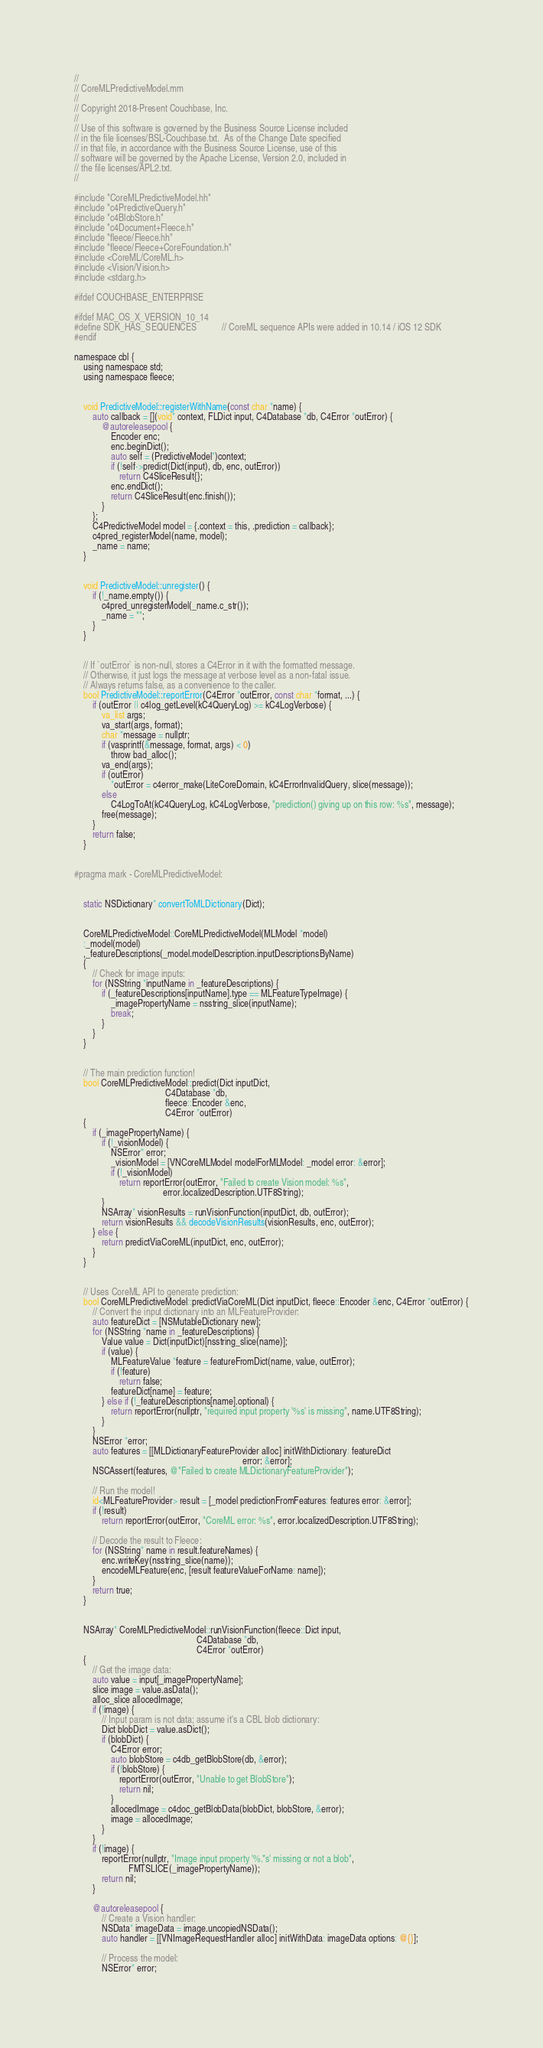<code> <loc_0><loc_0><loc_500><loc_500><_ObjectiveC_>//
// CoreMLPredictiveModel.mm
//
// Copyright 2018-Present Couchbase, Inc.
//
// Use of this software is governed by the Business Source License included
// in the file licenses/BSL-Couchbase.txt.  As of the Change Date specified
// in that file, in accordance with the Business Source License, use of this
// software will be governed by the Apache License, Version 2.0, included in
// the file licenses/APL2.txt.
//

#include "CoreMLPredictiveModel.hh"
#include "c4PredictiveQuery.h"
#include "c4BlobStore.h"
#include "c4Document+Fleece.h"
#include "fleece/Fleece.hh"
#include "fleece/Fleece+CoreFoundation.h"
#include <CoreML/CoreML.h>
#include <Vision/Vision.h>
#include <stdarg.h>

#ifdef COUCHBASE_ENTERPRISE

#ifdef MAC_OS_X_VERSION_10_14
#define SDK_HAS_SEQUENCES           // CoreML sequence APIs were added in 10.14 / iOS 12 SDK
#endif

namespace cbl {
    using namespace std;
    using namespace fleece;


    void PredictiveModel::registerWithName(const char *name) {
        auto callback = [](void* context, FLDict input, C4Database *db, C4Error *outError) {
            @autoreleasepool {
                Encoder enc;
                enc.beginDict();
                auto self = (PredictiveModel*)context;
                if (!self->predict(Dict(input), db, enc, outError))
                    return C4SliceResult{};
                enc.endDict();
                return C4SliceResult(enc.finish());
            }
        };
        C4PredictiveModel model = {.context = this, .prediction = callback};
        c4pred_registerModel(name, model);
        _name = name;
    }


    void PredictiveModel::unregister() {
        if (!_name.empty()) {
            c4pred_unregisterModel(_name.c_str());
            _name = "";
        }
    }


    // If `outError` is non-null, stores a C4Error in it with the formatted message.
    // Otherwise, it just logs the message at verbose level as a non-fatal issue.
    // Always returns false, as a convenience to the caller.
    bool PredictiveModel::reportError(C4Error *outError, const char *format, ...) {
        if (outError || c4log_getLevel(kC4QueryLog) >= kC4LogVerbose) {
            va_list args;
            va_start(args, format);
            char *message = nullptr;
            if (vasprintf(&message, format, args) < 0)
                throw bad_alloc();
            va_end(args);
            if (outError)
                *outError = c4error_make(LiteCoreDomain, kC4ErrorInvalidQuery, slice(message));
            else
                C4LogToAt(kC4QueryLog, kC4LogVerbose, "prediction() giving up on this row: %s", message);
            free(message);
        }
        return false;
    }


#pragma mark - CoreMLPredictiveModel:


    static NSDictionary* convertToMLDictionary(Dict);


    CoreMLPredictiveModel::CoreMLPredictiveModel(MLModel *model)
    :_model(model)
    ,_featureDescriptions(_model.modelDescription.inputDescriptionsByName)
    {
        // Check for image inputs:
        for (NSString *inputName in _featureDescriptions) {
            if (_featureDescriptions[inputName].type == MLFeatureTypeImage) {
                _imagePropertyName = nsstring_slice(inputName);
                break;
            }
        }
    }


    // The main prediction function!
    bool CoreMLPredictiveModel::predict(Dict inputDict,
                                        C4Database *db,
                                        fleece::Encoder &enc,
                                        C4Error *outError)
    {
        if (_imagePropertyName) {
            if (!_visionModel) {
                NSError* error;
                _visionModel = [VNCoreMLModel modelForMLModel: _model error: &error];
                if (!_visionModel)
                    return reportError(outError, "Failed to create Vision model: %s",
                                       error.localizedDescription.UTF8String);
            }
            NSArray* visionResults = runVisionFunction(inputDict, db, outError);
            return visionResults && decodeVisionResults(visionResults, enc, outError);
        } else {
            return predictViaCoreML(inputDict, enc, outError);
        }
    }


    // Uses CoreML API to generate prediction:
    bool CoreMLPredictiveModel::predictViaCoreML(Dict inputDict, fleece::Encoder &enc, C4Error *outError) {
        // Convert the input dictionary into an MLFeatureProvider:
        auto featureDict = [NSMutableDictionary new];
        for (NSString *name in _featureDescriptions) {
            Value value = Dict(inputDict)[nsstring_slice(name)];
            if (value) {
                MLFeatureValue *feature = featureFromDict(name, value, outError);
                if (!feature)
                    return false;
                featureDict[name] = feature;
            } else if (!_featureDescriptions[name].optional) {
                return reportError(nullptr, "required input property '%s' is missing", name.UTF8String);
            }
        }
        NSError *error;
        auto features = [[MLDictionaryFeatureProvider alloc] initWithDictionary: featureDict
                                                                          error: &error];
        NSCAssert(features, @"Failed to create MLDictionaryFeatureProvider");

        // Run the model!
        id<MLFeatureProvider> result = [_model predictionFromFeatures: features error: &error];
        if (!result)
            return reportError(outError, "CoreML error: %s", error.localizedDescription.UTF8String);

        // Decode the result to Fleece:
        for (NSString* name in result.featureNames) {
            enc.writeKey(nsstring_slice(name));
            encodeMLFeature(enc, [result featureValueForName: name]);
        }
        return true;
    }


    NSArray* CoreMLPredictiveModel::runVisionFunction(fleece::Dict input,
                                                      C4Database *db,
                                                      C4Error *outError)
    {
        // Get the image data:
        auto value = input[_imagePropertyName];
        slice image = value.asData();
        alloc_slice allocedImage;
        if (!image) {
            // Input param is not data; assume it's a CBL blob dictionary:
            Dict blobDict = value.asDict();
            if (blobDict) {
                C4Error error;
                auto blobStore = c4db_getBlobStore(db, &error);
                if (!blobStore) {
                    reportError(outError, "Unable to get BlobStore");
                    return nil;
                }
                allocedImage = c4doc_getBlobData(blobDict, blobStore, &error);
                image = allocedImage;
            }
        }
        if (!image) {
            reportError(nullptr, "Image input property '%.*s' missing or not a blob",
                        FMTSLICE(_imagePropertyName));
            return nil;
        }

        @autoreleasepool {
            // Create a Vision handler:
            NSData* imageData = image.uncopiedNSData();
            auto handler = [[VNImageRequestHandler alloc] initWithData: imageData options: @{}];

            // Process the model:
            NSError* error;</code> 